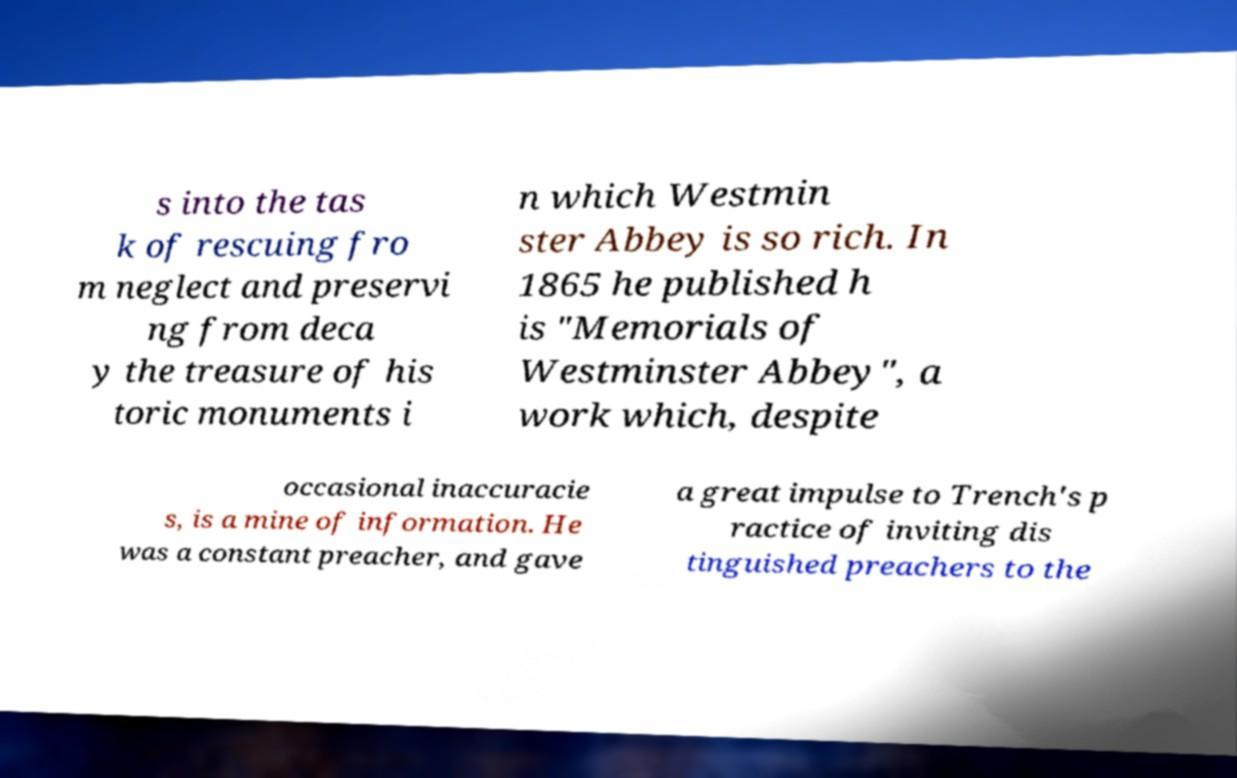I need the written content from this picture converted into text. Can you do that? s into the tas k of rescuing fro m neglect and preservi ng from deca y the treasure of his toric monuments i n which Westmin ster Abbey is so rich. In 1865 he published h is "Memorials of Westminster Abbey", a work which, despite occasional inaccuracie s, is a mine of information. He was a constant preacher, and gave a great impulse to Trench's p ractice of inviting dis tinguished preachers to the 